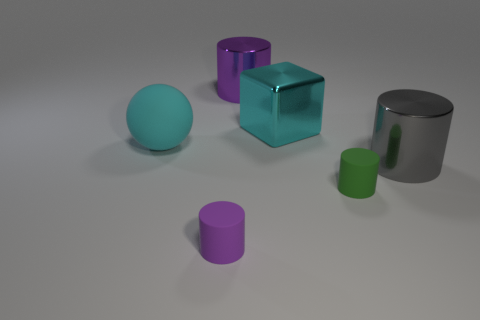What material is the sphere?
Make the answer very short. Rubber. What shape is the tiny thing in front of the small thing right of the cylinder that is behind the large cyan rubber object?
Your answer should be compact. Cylinder. Is the number of small green rubber objects that are on the right side of the cyan cube greater than the number of red cubes?
Your answer should be compact. Yes. There is a large gray shiny object; is its shape the same as the purple thing that is on the right side of the tiny purple rubber thing?
Keep it short and to the point. Yes. There is a big thing that is the same color as the matte ball; what shape is it?
Your response must be concise. Cube. What number of large objects are on the right side of the thing that is left of the purple object left of the purple metal object?
Give a very brief answer. 3. What is the color of the matte sphere that is the same size as the metal block?
Provide a short and direct response. Cyan. What size is the metal cube that is in front of the big shiny cylinder to the left of the gray thing?
Keep it short and to the point. Large. What number of other things are there of the same size as the cyan rubber sphere?
Keep it short and to the point. 3. How many small purple metal things are there?
Provide a succinct answer. 0. 